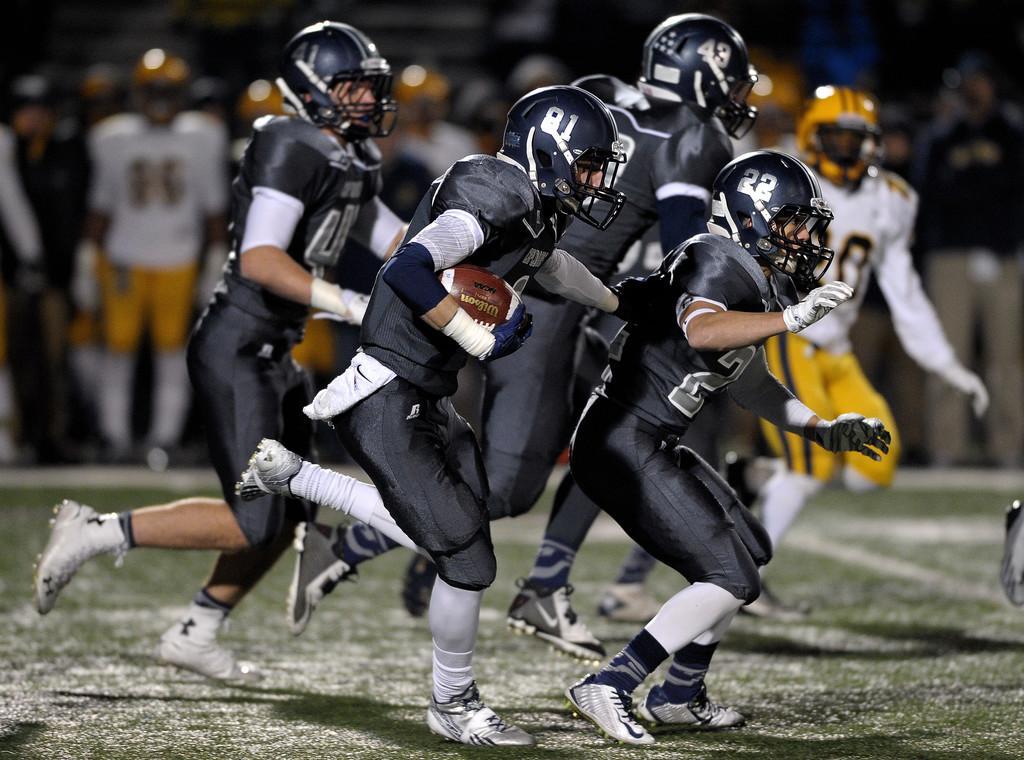In one or two sentences, can you explain what this image depicts? In this picture we can see some people are playing a game, they are wearing helmets, a person in the front is holding a ball, at the bottom there is grass, we can see some people in the background. 